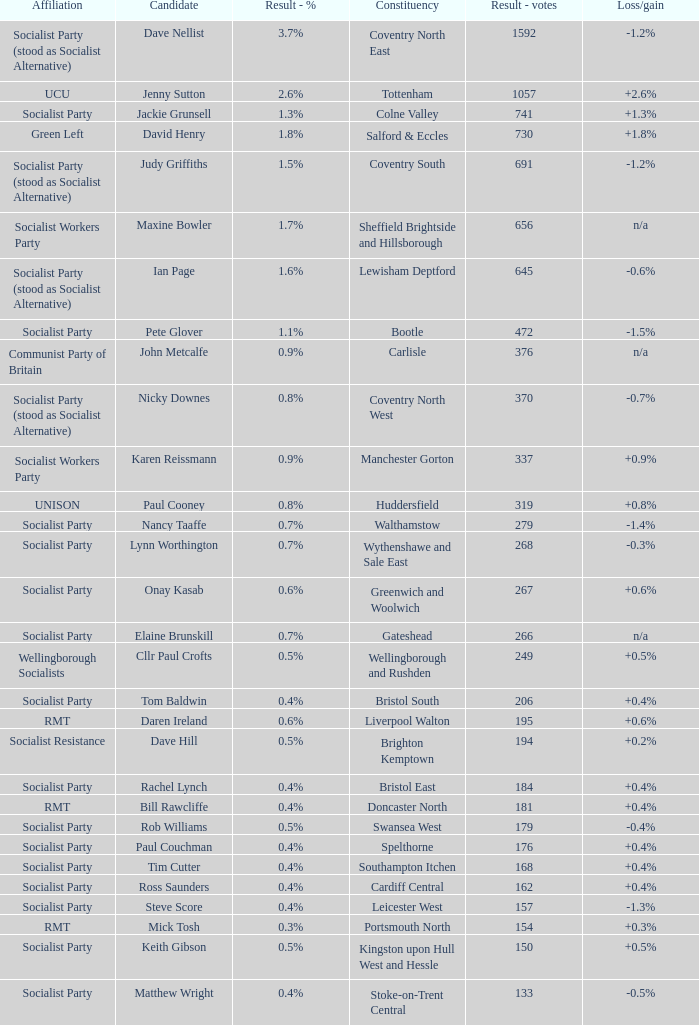What is every affiliation for candidate Daren Ireland? RMT. 